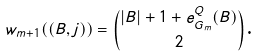<formula> <loc_0><loc_0><loc_500><loc_500>w _ { m + 1 } ( ( B , j ) ) = \binom { | B | + 1 + e _ { G _ { m } } ^ { Q } ( B ) } { 2 } \text  .</formula> 